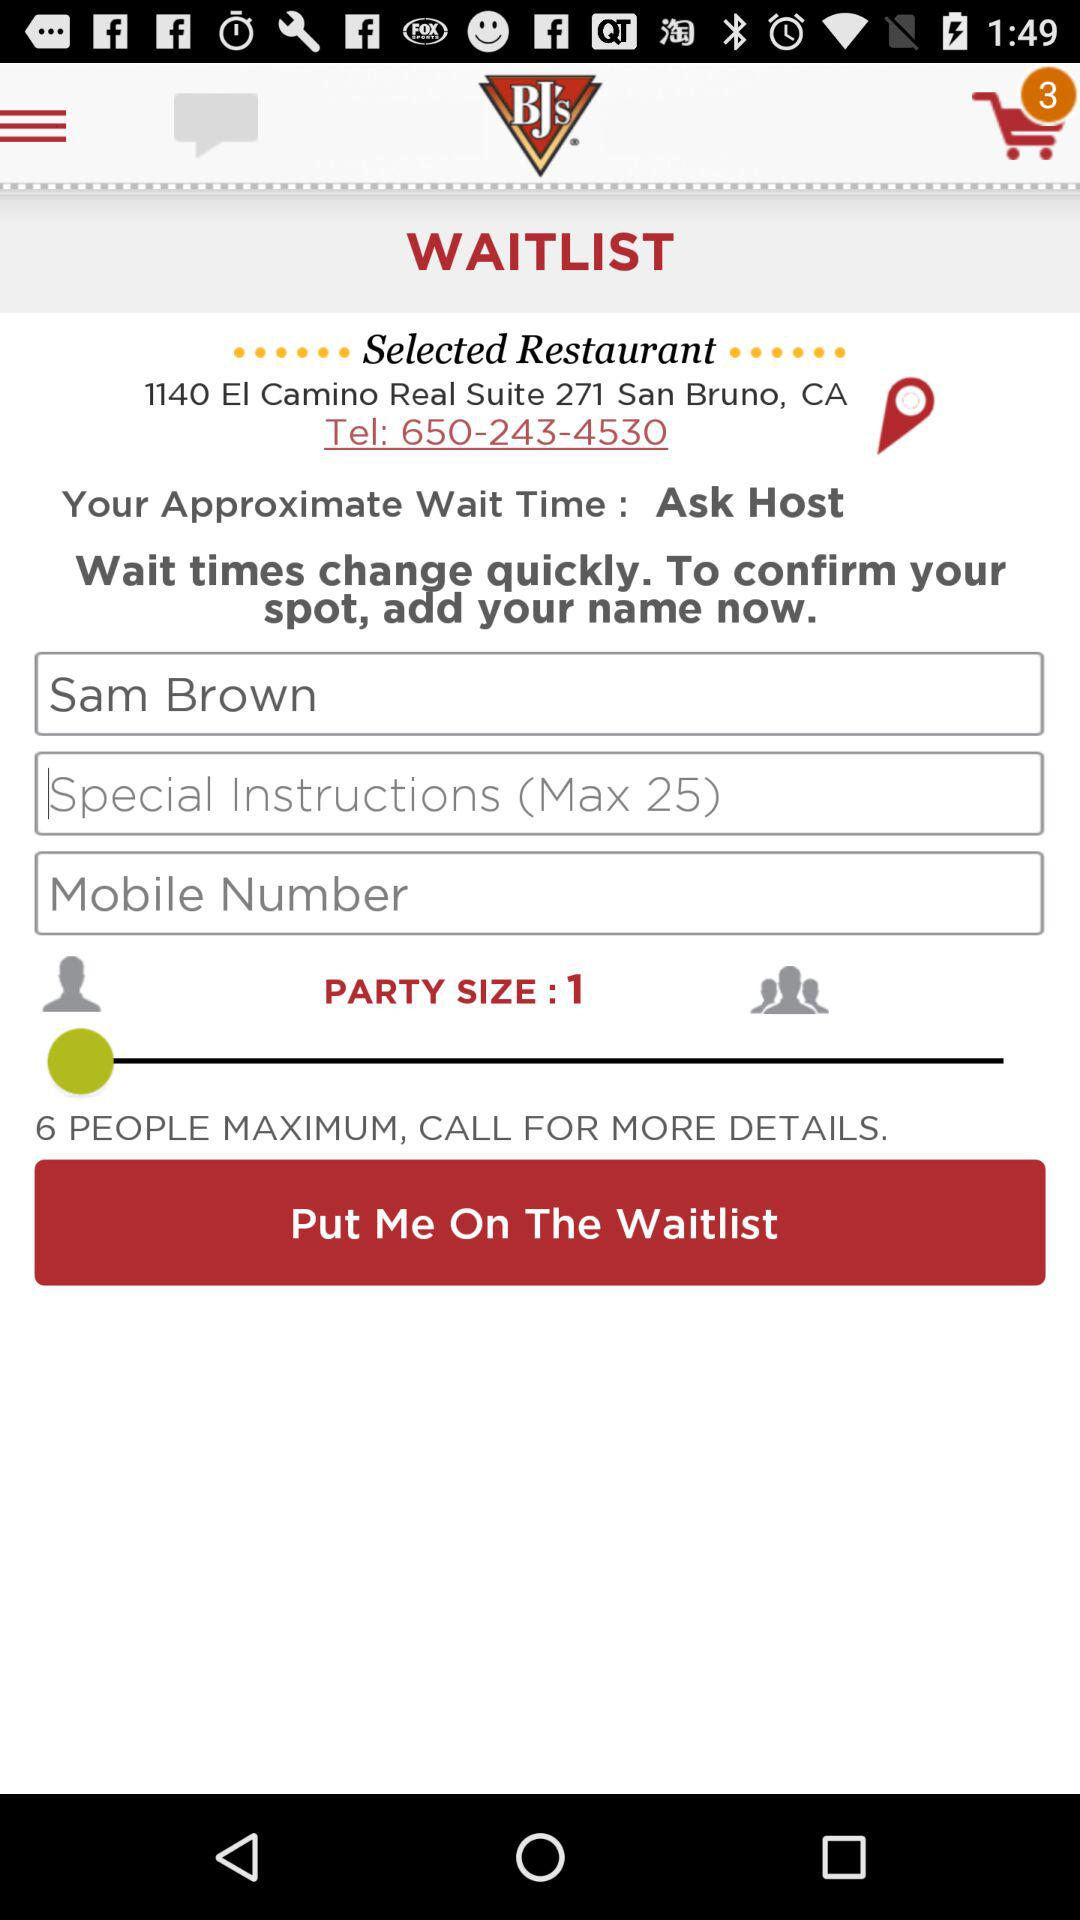What is the telephone number of the selected restaurant? The telephone number is 650-243-4530. 